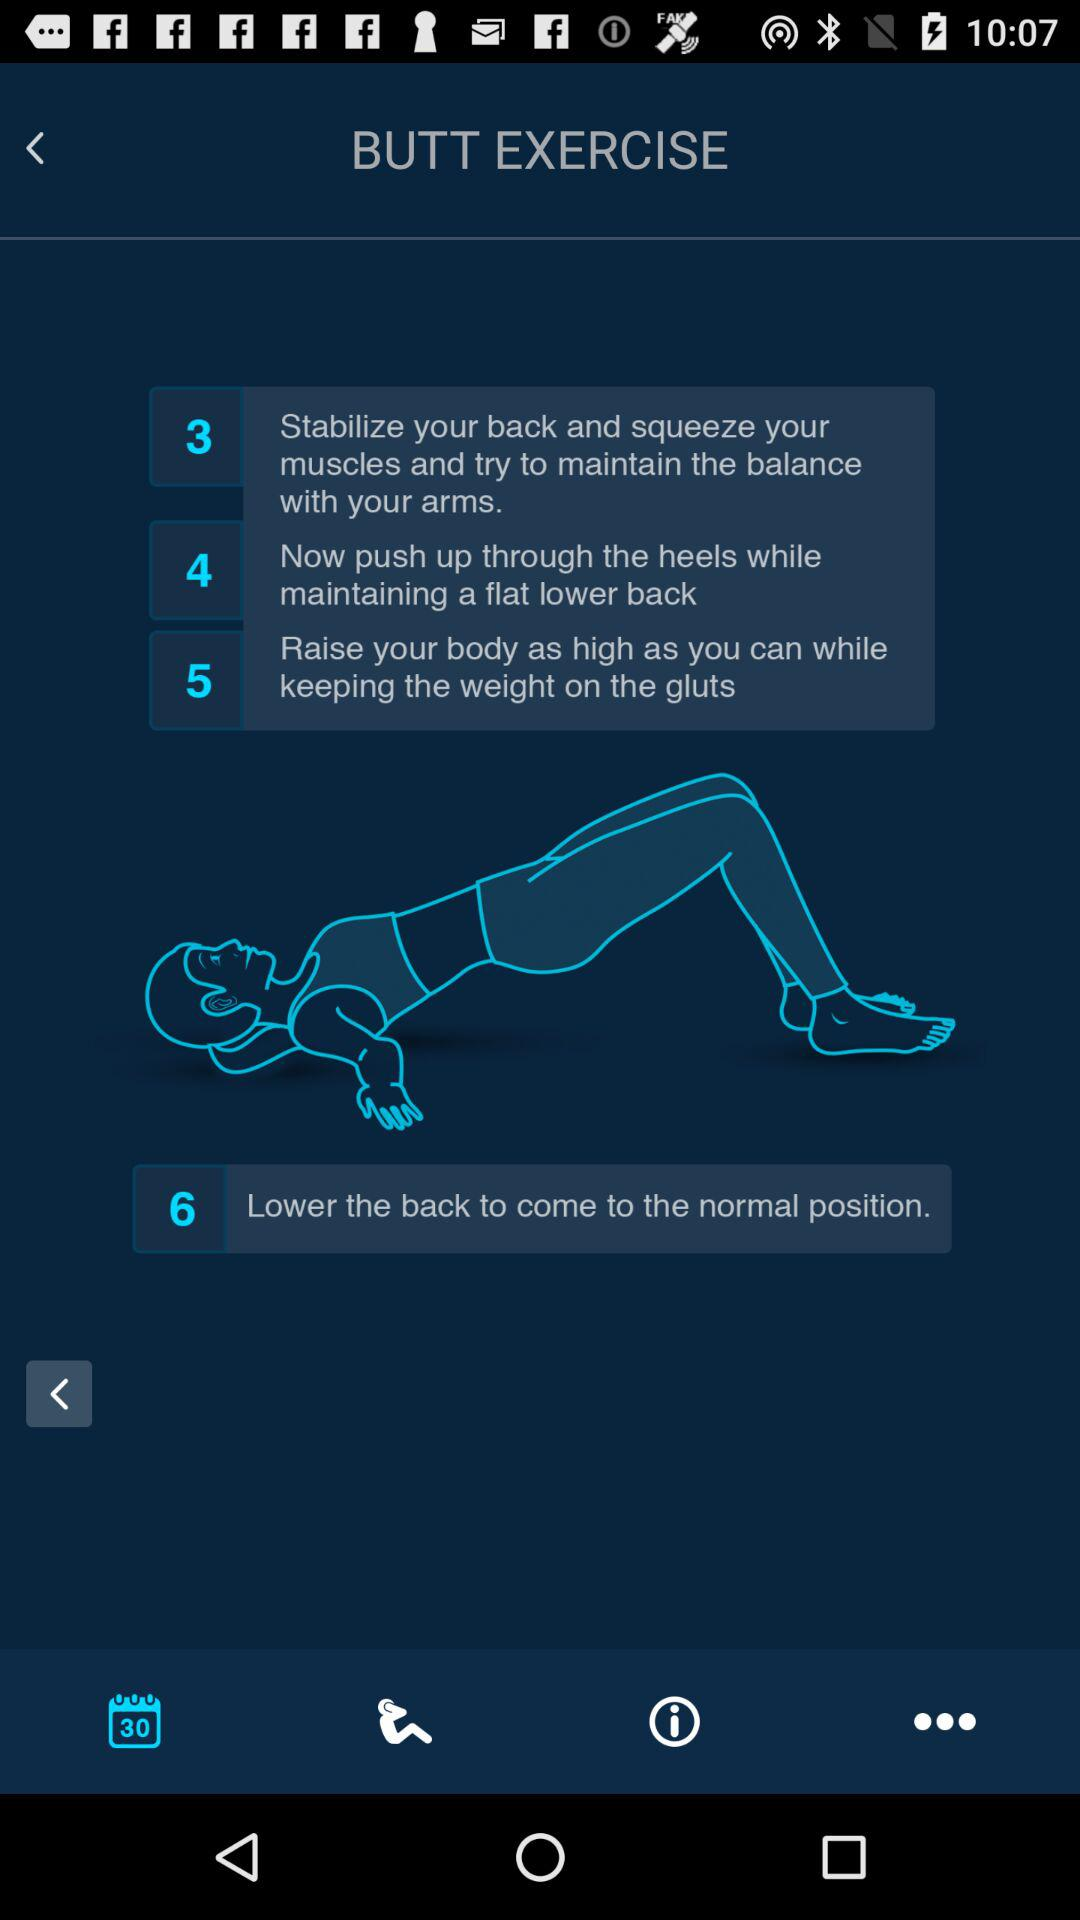How many steps are there in the exercise instructions?
Answer the question using a single word or phrase. 6 